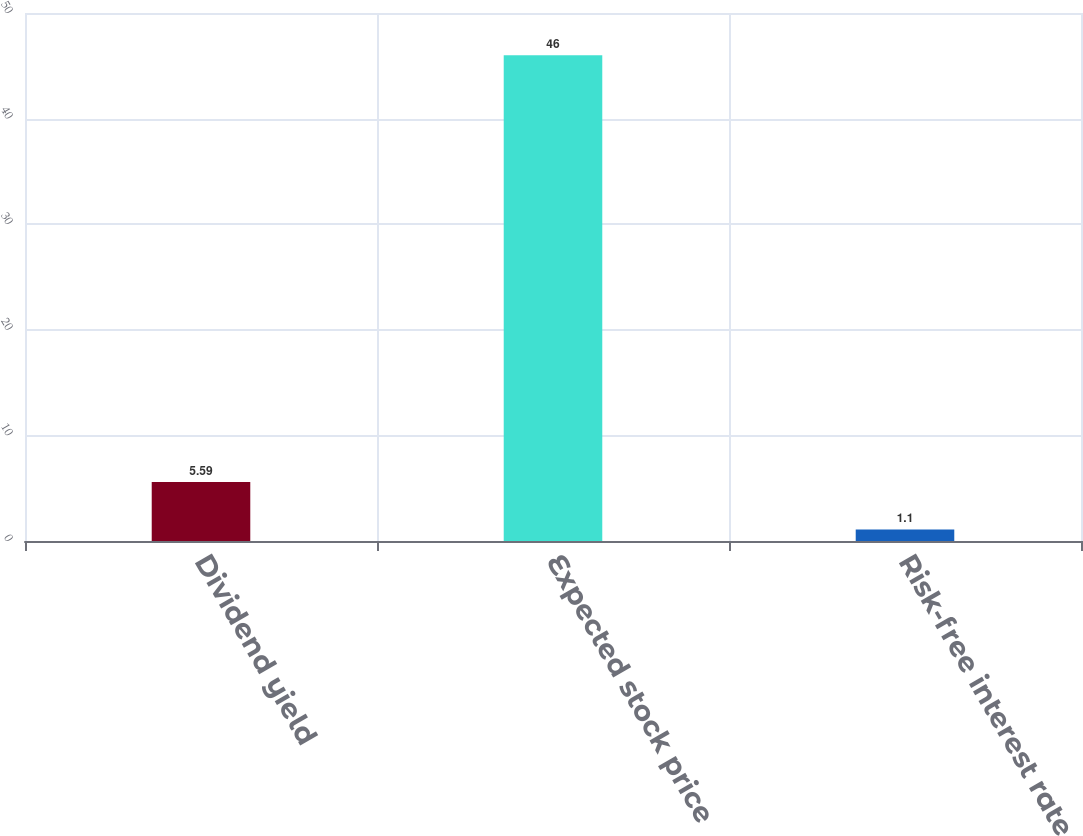Convert chart to OTSL. <chart><loc_0><loc_0><loc_500><loc_500><bar_chart><fcel>Dividend yield<fcel>Expected stock price<fcel>Risk-free interest rate<nl><fcel>5.59<fcel>46<fcel>1.1<nl></chart> 